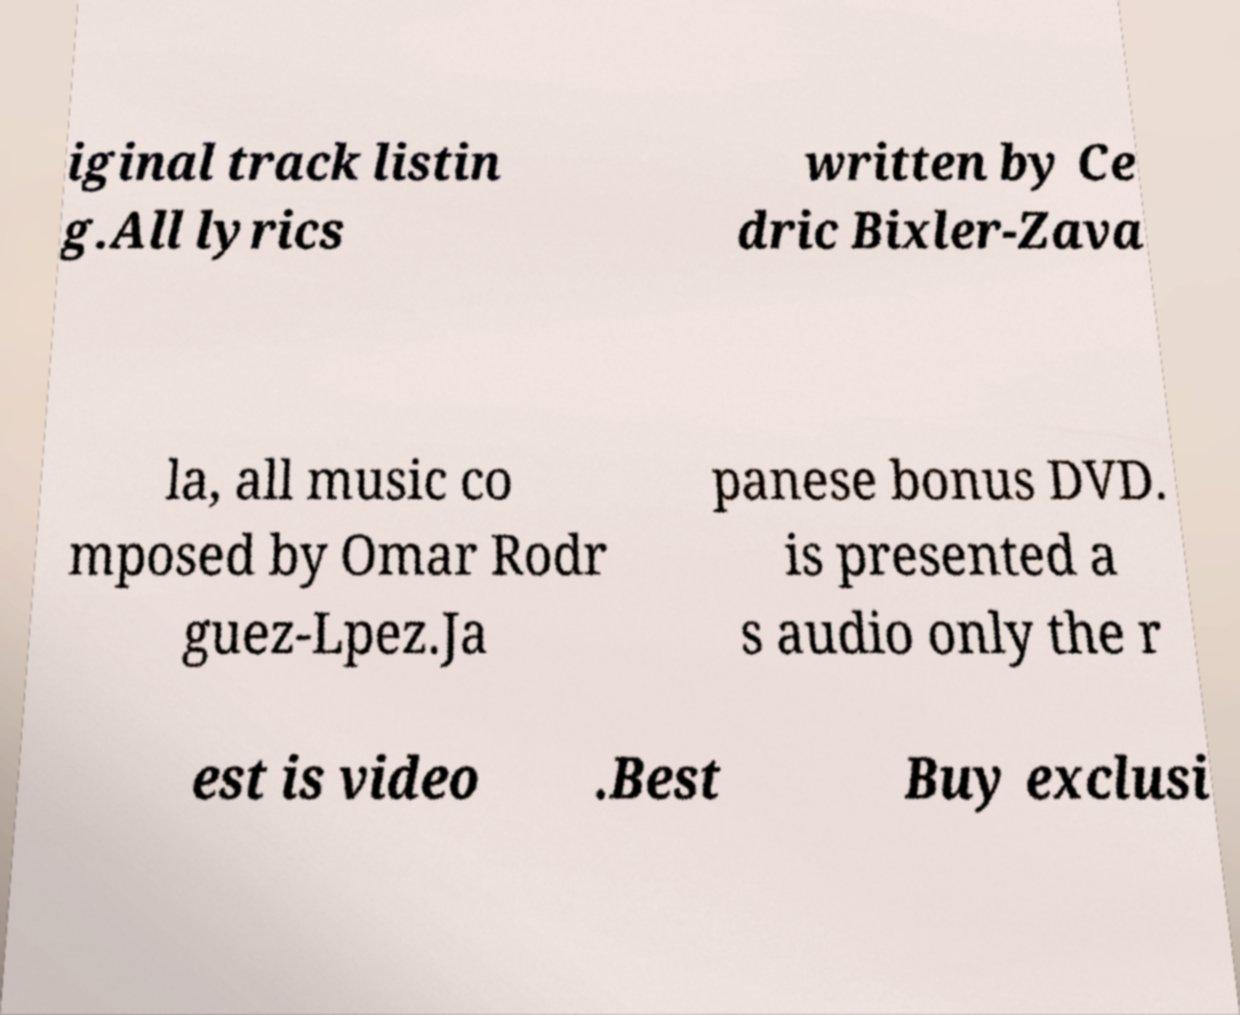Could you assist in decoding the text presented in this image and type it out clearly? iginal track listin g.All lyrics written by Ce dric Bixler-Zava la, all music co mposed by Omar Rodr guez-Lpez.Ja panese bonus DVD. is presented a s audio only the r est is video .Best Buy exclusi 